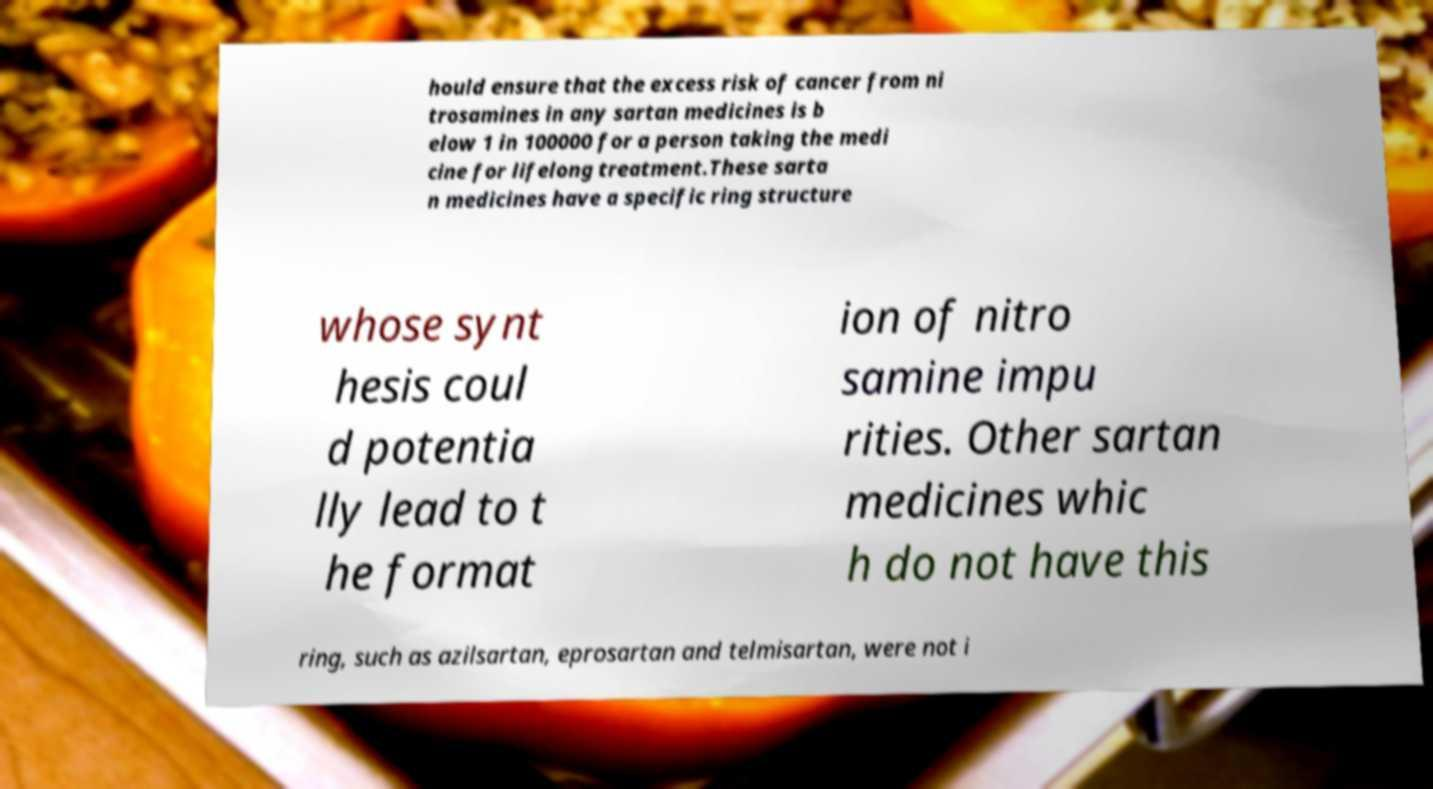Please identify and transcribe the text found in this image. hould ensure that the excess risk of cancer from ni trosamines in any sartan medicines is b elow 1 in 100000 for a person taking the medi cine for lifelong treatment.These sarta n medicines have a specific ring structure whose synt hesis coul d potentia lly lead to t he format ion of nitro samine impu rities. Other sartan medicines whic h do not have this ring, such as azilsartan, eprosartan and telmisartan, were not i 